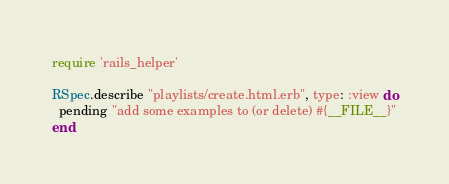Convert code to text. <code><loc_0><loc_0><loc_500><loc_500><_Ruby_>require 'rails_helper'

RSpec.describe "playlists/create.html.erb", type: :view do
  pending "add some examples to (or delete) #{__FILE__}"
end
</code> 